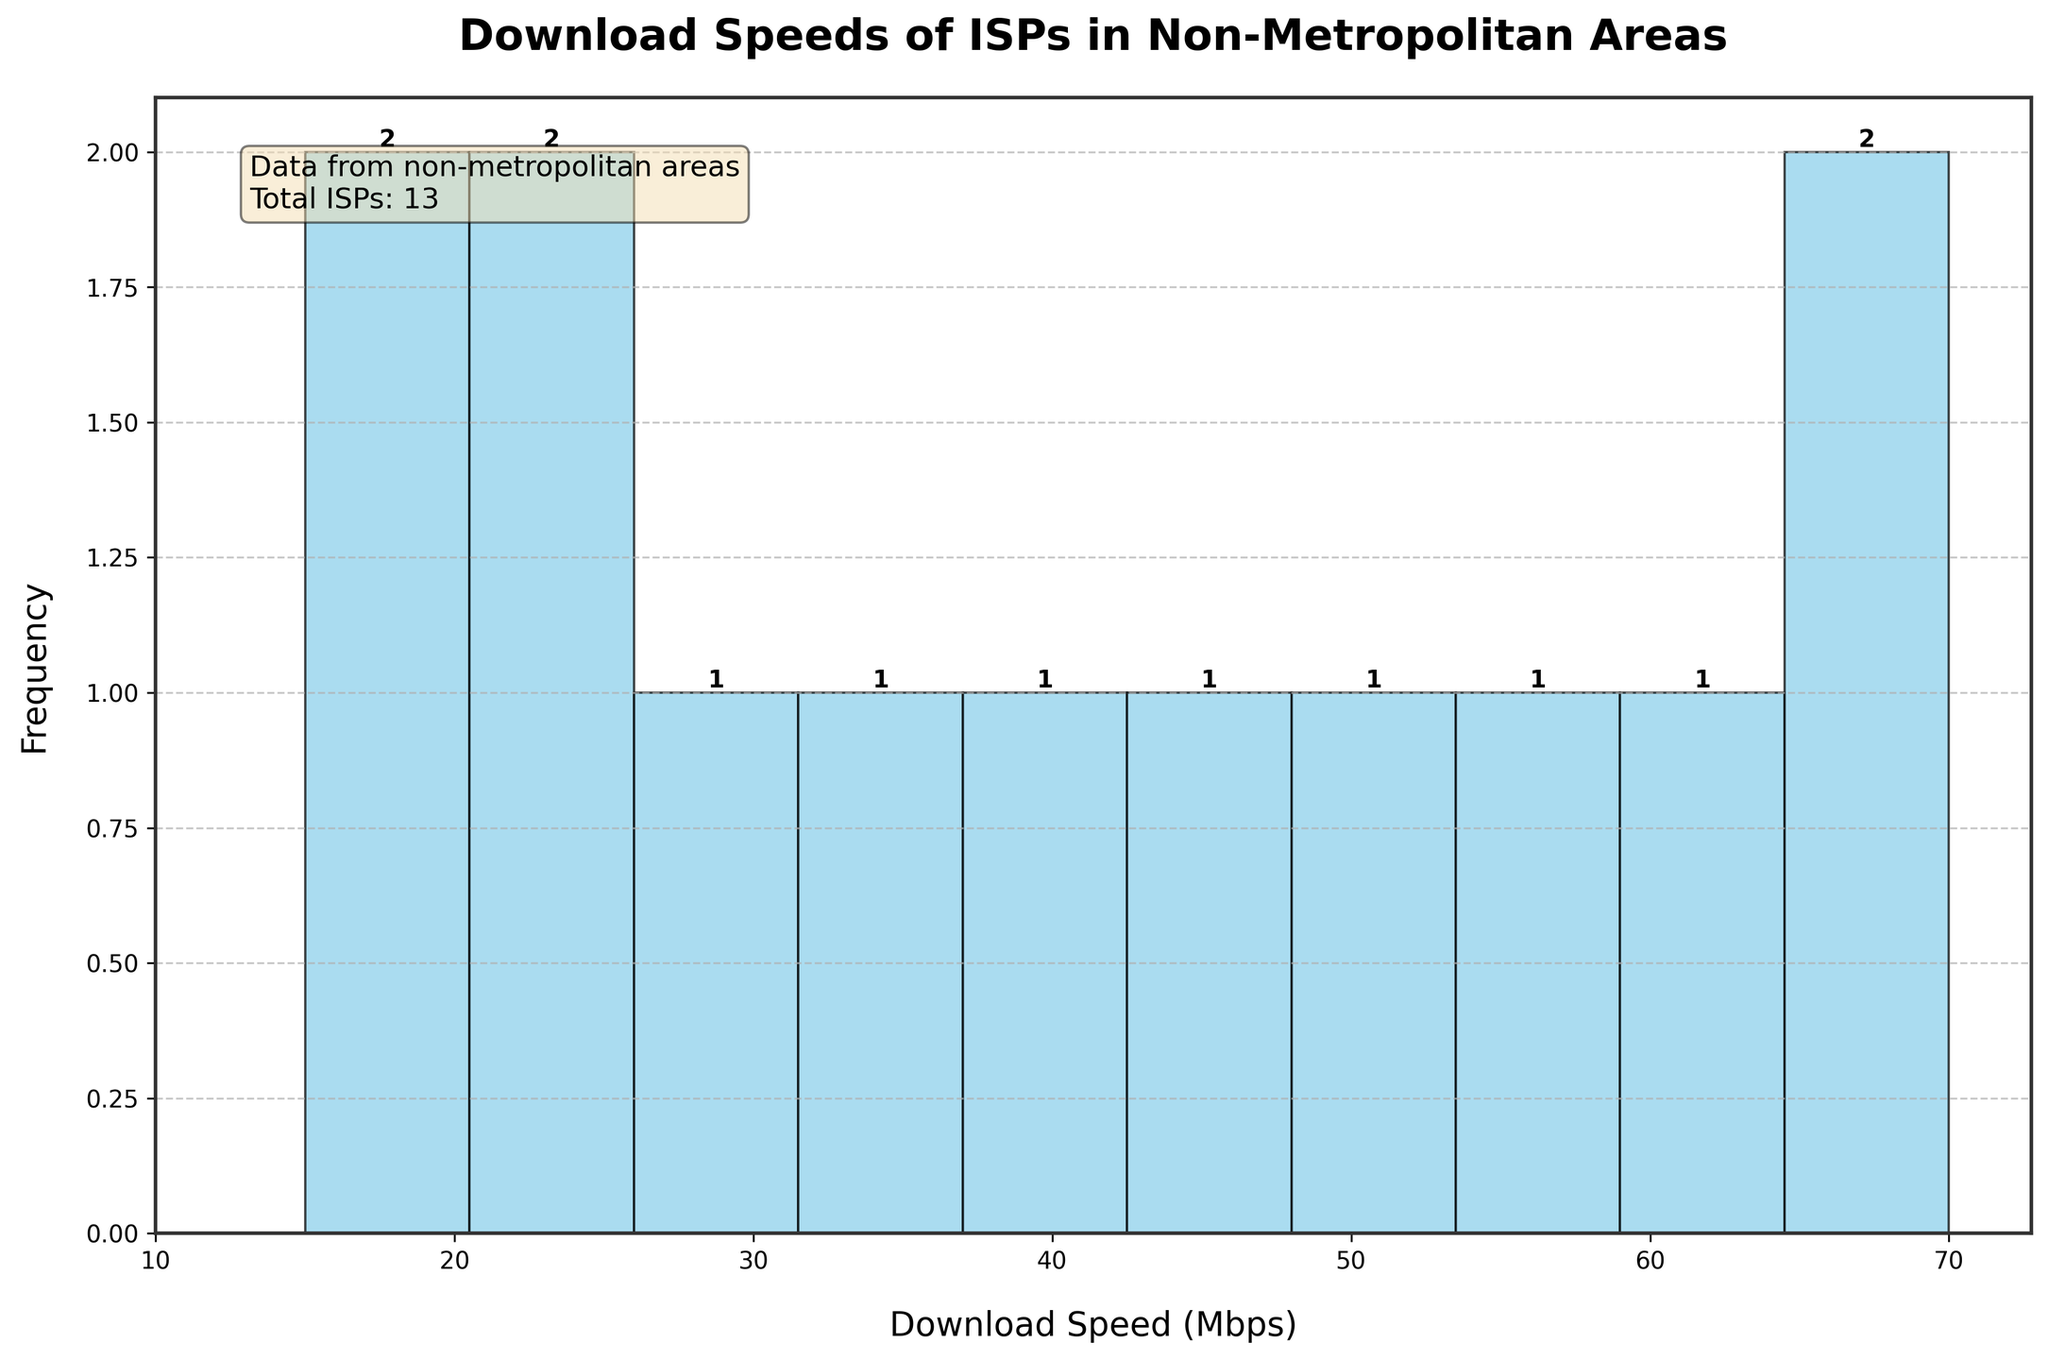What is the title of the plot? The title of the plot is located at the top of the figure and provides a summary of what the plot is about. In this case, it is 'Download Speeds of ISPs in Non-Metropolitan Areas'.
Answer: Download Speeds of ISPs in Non-Metropolitan Areas How many ISPs are represented in the histogram? The number of ISPs is indicated in the additional information box located in the top-left corner of the figure. It states: 'Total ISPs: 13'.
Answer: 13 What is the range of download speeds represented on the x-axis? The x-axis ticks indicate the range of download speeds, which spans from 10 Mbps to 70 Mbps in increments of 10 Mbps.
Answer: 10 Mbps to 70 Mbps Which download speed category has the highest frequency? By examining the heights of the bars in the histogram, the download speed category with the highest bar represents the highest frequency. This can be seen around the category of 60 to 70 Mbps.
Answer: 60 to 70 Mbps How many ISPs offer download speeds between 20 and 30 Mbps? Looking at the histogram, the bar corresponding to the 20 to 30 Mbps range shows a frequency value at the top of the bar indicating the number of ISPs.
Answer: 2 ISPs Are there more ISPs offering speeds above 40 Mbps or below 40 Mbps? To determine this, count the number of bars and their frequencies for download speeds above 40 Mbps and below 40 Mbps. Bars to the right of 40 Mbps indicate more ISPs in higher-speed categories.
Answer: Above 40 Mbps What is the total frequency of ISPs offering download speeds between 10 and 30 Mbps? Sum the frequencies of the bars corresponding to ranges 10-20 Mbps and 20-30 Mbps. The histogram shows 1 for 10-20 Mbps and 2 for 20-30 Mbps. Thus, 1 + 2 = 3 ISPs.
Answer: 3 ISPs What is the average download speed of ISPs in the dataset? To find the average, sum all the Mbps values and divide by the number of ISPs: (15 + 18 + 22 + 25 + 30 + 35 + 40 + 45 + 50 + 55 + 60 + 65 + 70) / 13 = 42.3 Mbps.
Answer: 42.3 Mbps Which download speed category has the lowest frequency? By observing the histogram, the smallest bar represents the category with the lowest frequency. Here, download speeds around 10 to 20 Mbps have the lowest frequency.
Answer: 10 to 20 Mbps What download speed does the histogram's peak most likely represent? The highest peak in the histogram represents the speed that appears most frequently. The histogram shows the highest bar in the 60 to 70 Mbps range.
Answer: 60 to 70 Mbps 